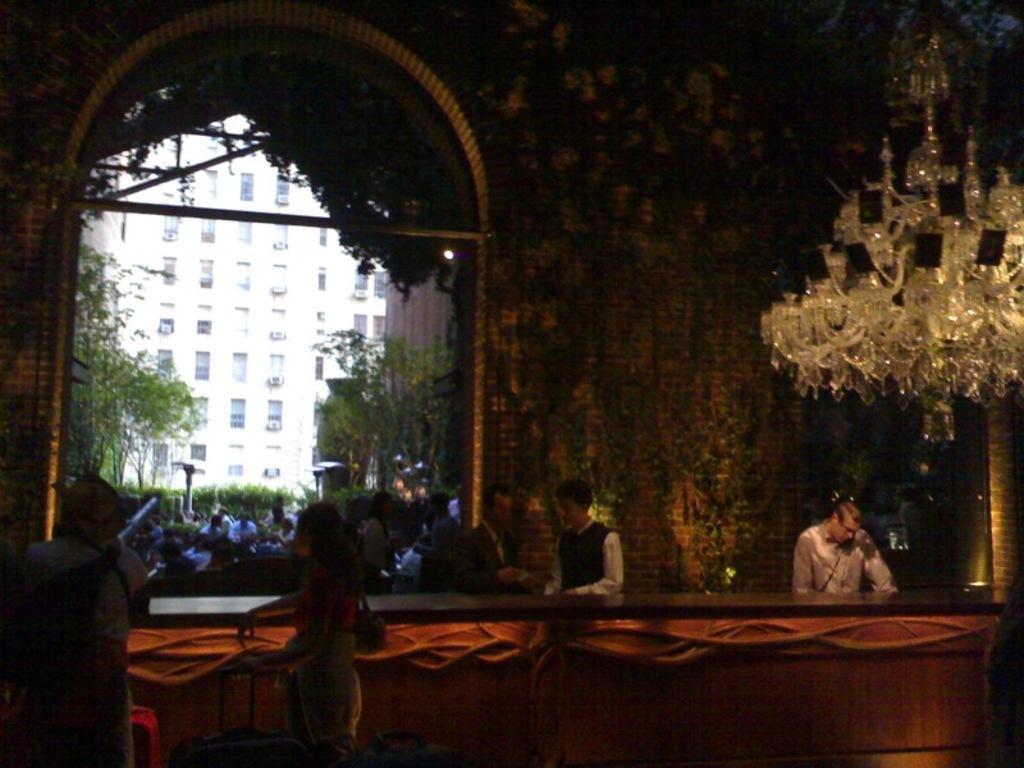Describe this image in one or two sentences. It look like a reception and a person is attending a call,in front of the reception there are two people standing beside the table and behind the reception there is a way and a lot of people gathered at the way and in the background there is a big building. 